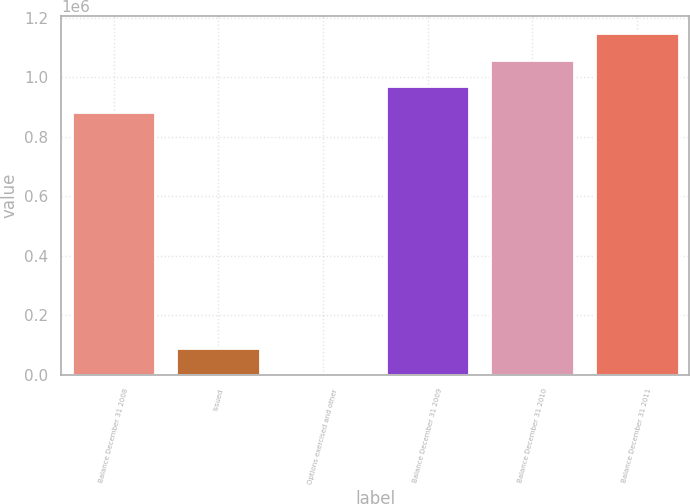Convert chart to OTSL. <chart><loc_0><loc_0><loc_500><loc_500><bar_chart><fcel>Balance December 31 2008<fcel>Issued<fcel>Options exercised and other<fcel>Balance December 31 2009<fcel>Balance December 31 2010<fcel>Balance December 31 2011<nl><fcel>881423<fcel>89151.6<fcel>523<fcel>970052<fcel>1.05868e+06<fcel>1.14731e+06<nl></chart> 